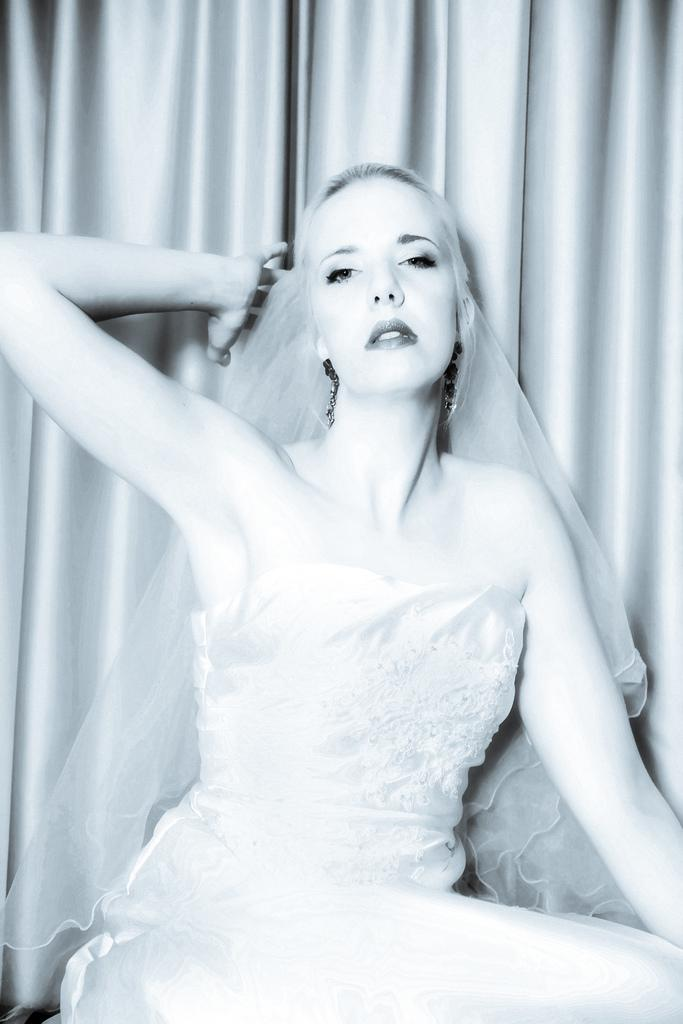Who is the main subject in the image? There is a lady in the image. What is located behind the lady? There is a curtain behind the lady. What type of skin condition can be seen on the lady's face in the image? There is no indication of any skin condition on the lady's face in the image. Can you see any twigs on the ground in the image? There is no mention of twigs or any ground in the image; it only features a lady and a curtain. 